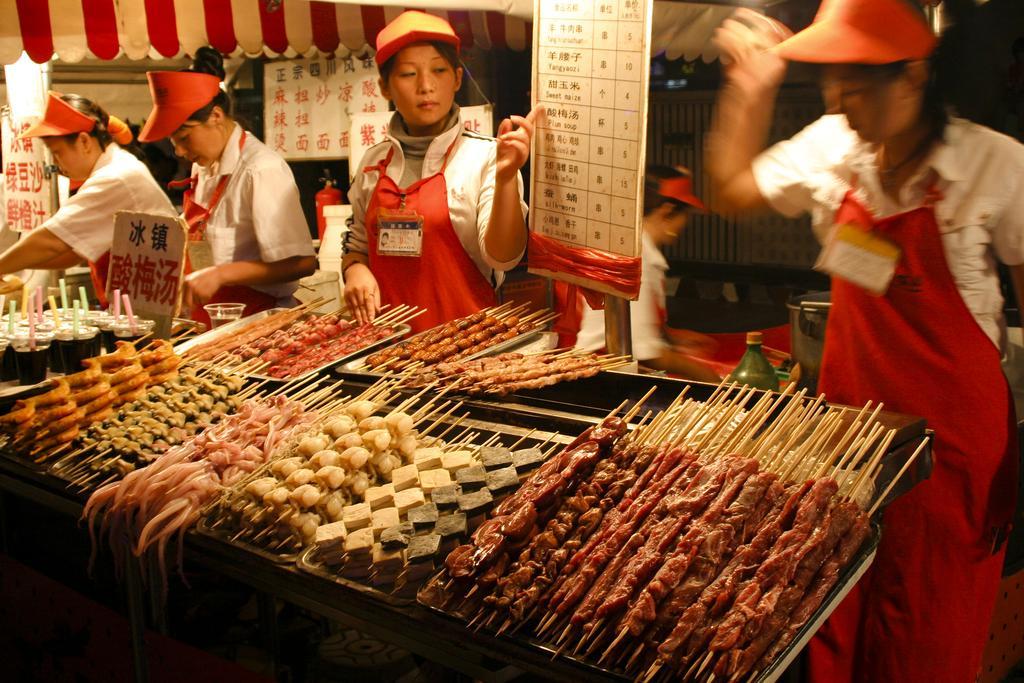In one or two sentences, can you explain what this image depicts? In the image we can see there are people standing, wearing the same costume, caps and identity cards. Here we can see food items, board and text on the board.  